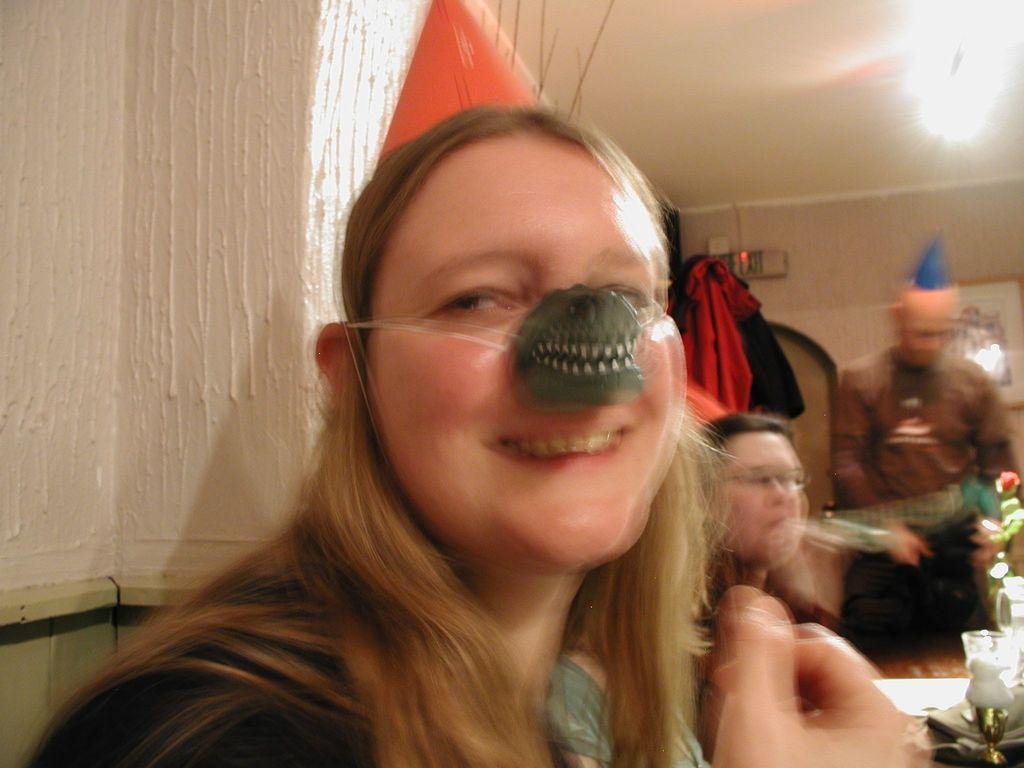What can be observed about the quality of the image? The image is blurry. Can you identify any subjects in the image? Yes, there are people in the image. What is located on the right side of the image? There is an object on the right side of the image. What can be seen in the background of the image? There is a wall in the background of the image. What type of coach is the person wearing in the image? There is no coach visible in the image, as it is blurry and only shows people and an object on the right side. What color is the sweater worn by the authority figure in the image? There is no authority figure or sweater present in the image. 